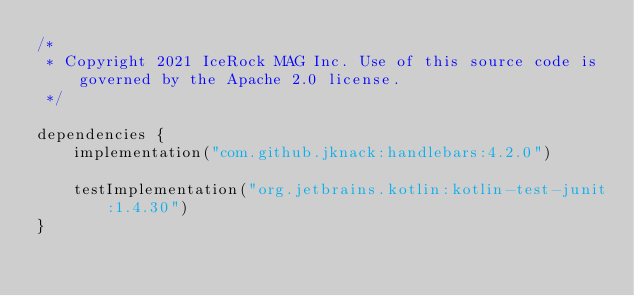<code> <loc_0><loc_0><loc_500><loc_500><_Kotlin_>/*
 * Copyright 2021 IceRock MAG Inc. Use of this source code is governed by the Apache 2.0 license.
 */

dependencies {
    implementation("com.github.jknack:handlebars:4.2.0")

    testImplementation("org.jetbrains.kotlin:kotlin-test-junit:1.4.30")
}
</code> 